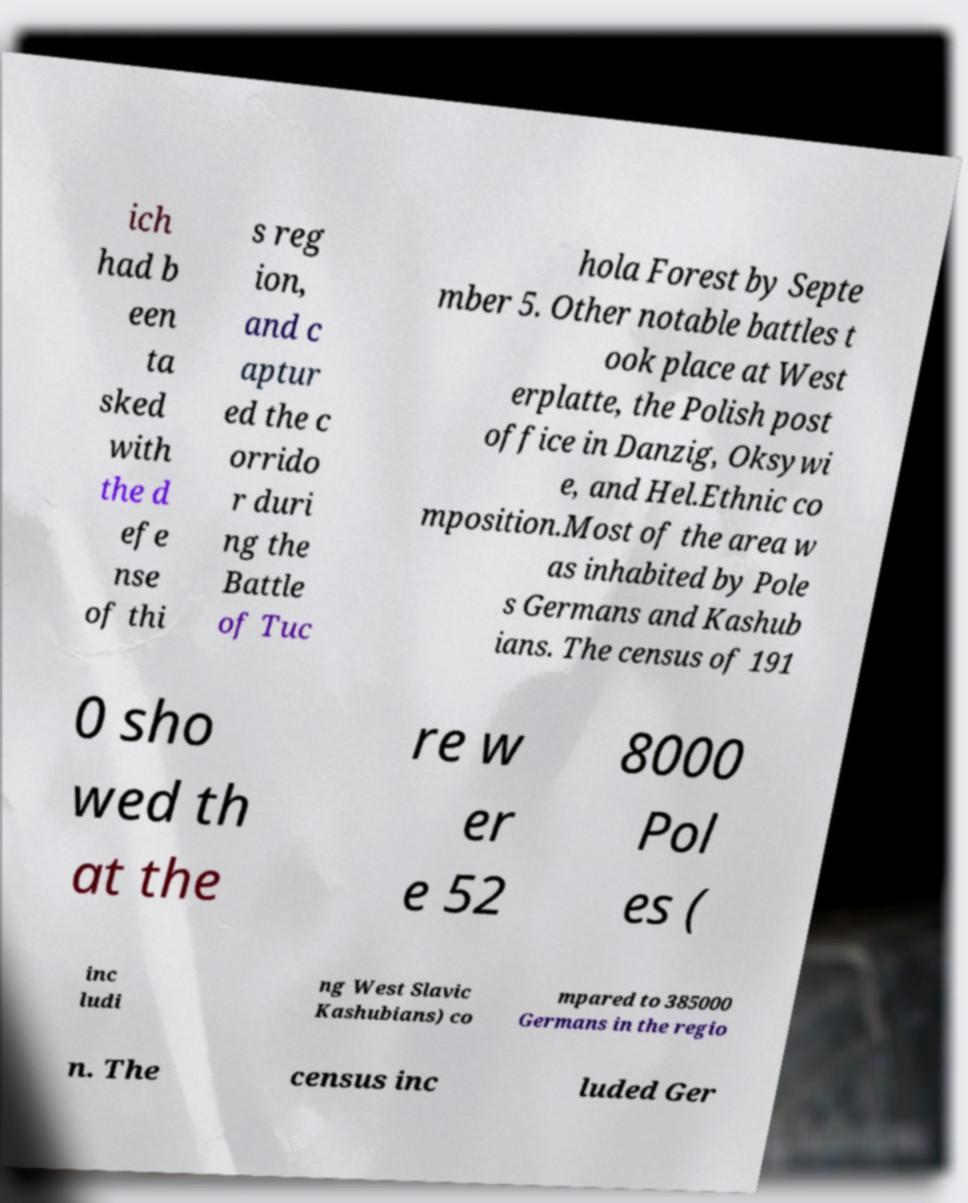What messages or text are displayed in this image? I need them in a readable, typed format. ich had b een ta sked with the d efe nse of thi s reg ion, and c aptur ed the c orrido r duri ng the Battle of Tuc hola Forest by Septe mber 5. Other notable battles t ook place at West erplatte, the Polish post office in Danzig, Oksywi e, and Hel.Ethnic co mposition.Most of the area w as inhabited by Pole s Germans and Kashub ians. The census of 191 0 sho wed th at the re w er e 52 8000 Pol es ( inc ludi ng West Slavic Kashubians) co mpared to 385000 Germans in the regio n. The census inc luded Ger 